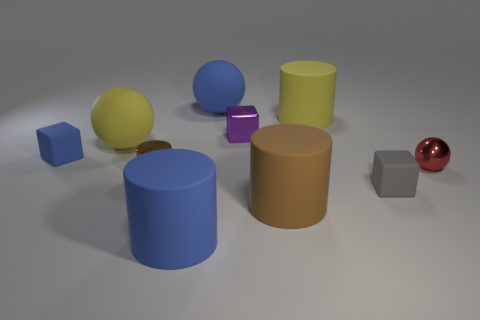Subtract all yellow matte spheres. How many spheres are left? 2 Subtract all spheres. How many objects are left? 7 Subtract 1 cubes. How many cubes are left? 2 Subtract all yellow cylinders. How many cylinders are left? 3 Subtract all blue blocks. Subtract all brown spheres. How many blocks are left? 2 Subtract all yellow cylinders. How many purple balls are left? 0 Subtract all matte balls. Subtract all tiny brown cylinders. How many objects are left? 7 Add 7 tiny gray objects. How many tiny gray objects are left? 8 Add 7 large yellow objects. How many large yellow objects exist? 9 Subtract 1 purple cubes. How many objects are left? 9 